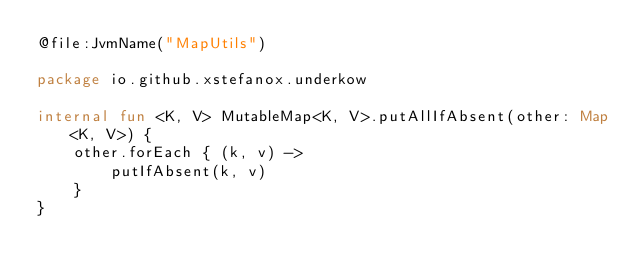Convert code to text. <code><loc_0><loc_0><loc_500><loc_500><_Kotlin_>@file:JvmName("MapUtils")

package io.github.xstefanox.underkow

internal fun <K, V> MutableMap<K, V>.putAllIfAbsent(other: Map<K, V>) {
    other.forEach { (k, v) ->
        putIfAbsent(k, v)
    }
}
</code> 